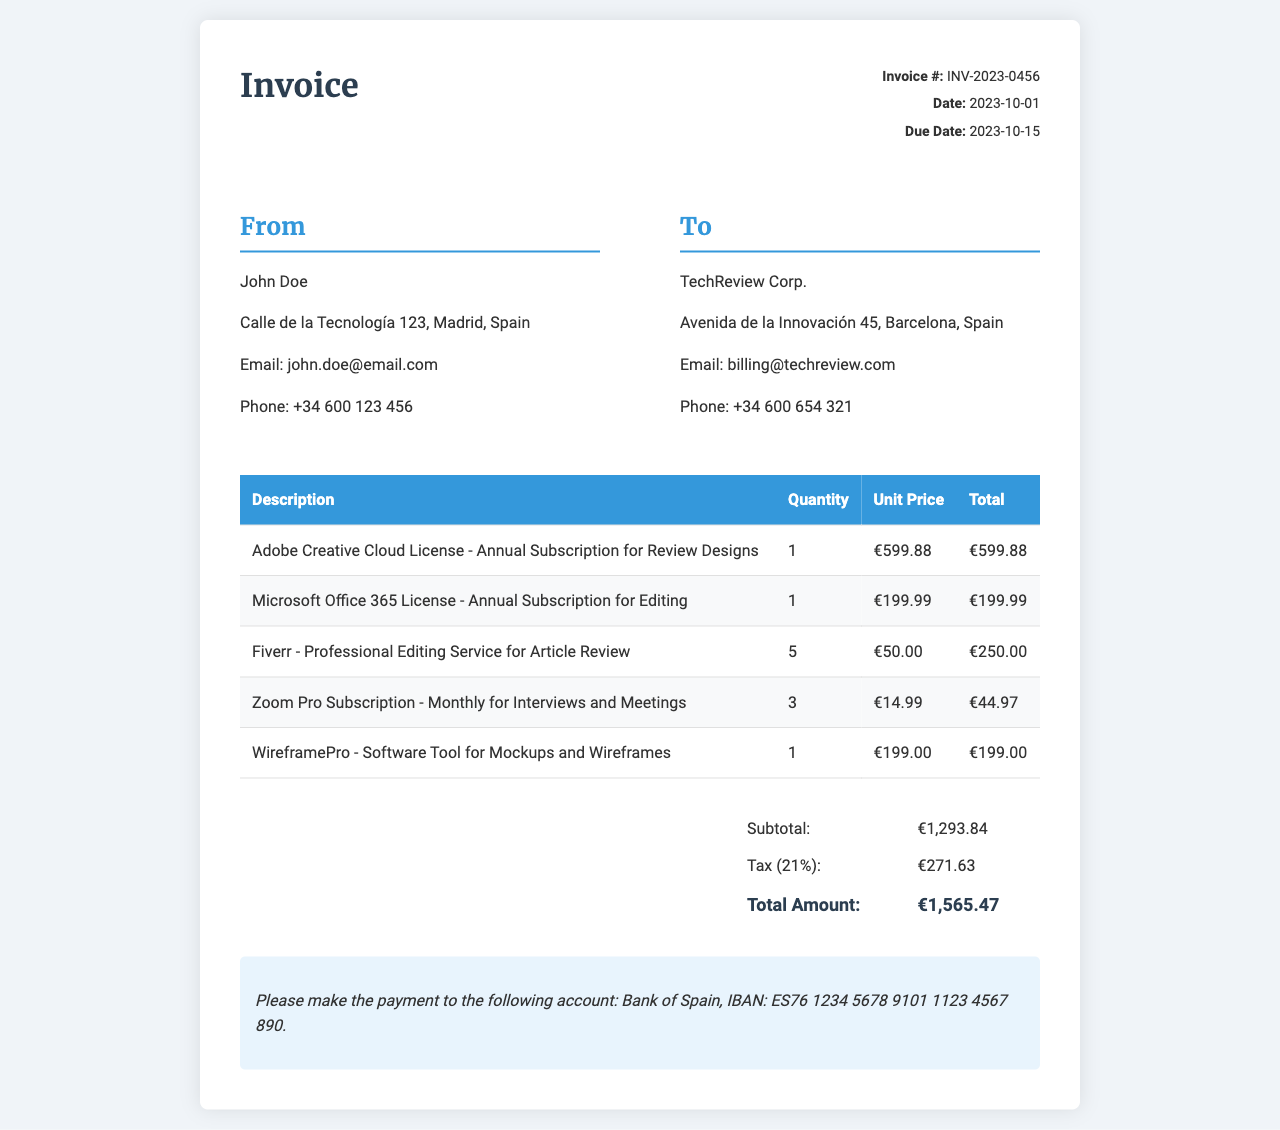what is the invoice number? The invoice number is found at the top of the document, labeled clearly for reference.
Answer: INV-2023-0456 what is the total amount due? The total amount due is calculated by adding the subtotal and tax as presented in the totals section of the document.
Answer: €1,565.47 what is the due date of the invoice? The due date is specified in the invoice details section and indicates when payment is expected.
Answer: 2023-10-15 who is the recipient of the invoice? The recipient's information is provided in the billing section, identifying the entity to which the invoice is addressed.
Answer: TechReview Corp how many Fiverr services were billed? The number of Fiverr services can be deduced from the line items where this service is mentioned and its quantity listed.
Answer: 5 what percentage is the tax applied to the invoice? The tax percentage is mentioned explicitly in the totals section, reflecting the rate applied to the subtotal.
Answer: 21% what is the subtotal before tax? The subtotal is noted before tax is added, providing a clear breakdown of the costs associated with the invoice.
Answer: €1,293.84 what is the license fee for Adobe Creative Cloud? The license fee is listed for the Adobe Creative Cloud in the line items section with its associated costs.
Answer: €599.88 which subscription is billed monthly? The document specifies which subscription is billed on a monthly basis among the listed items in the line items.
Answer: Zoom Pro Subscription 